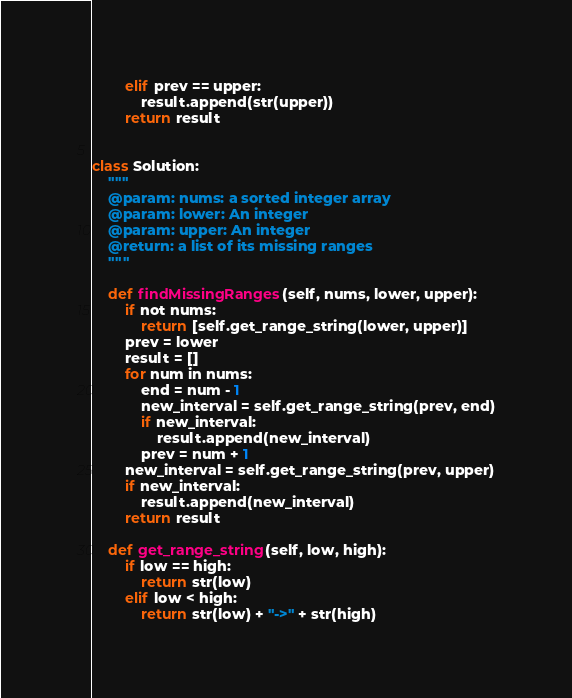<code> <loc_0><loc_0><loc_500><loc_500><_Python_>        elif prev == upper:
            result.append(str(upper))
        return result


class Solution:
    """
    @param: nums: a sorted integer array
    @param: lower: An integer
    @param: upper: An integer
    @return: a list of its missing ranges
    """

    def findMissingRanges(self, nums, lower, upper):
        if not nums:
            return [self.get_range_string(lower, upper)]
        prev = lower
        result = []
        for num in nums:
            end = num - 1
            new_interval = self.get_range_string(prev, end)
            if new_interval:
                result.append(new_interval)
            prev = num + 1
        new_interval = self.get_range_string(prev, upper)
        if new_interval:
            result.append(new_interval)
        return result

    def get_range_string(self, low, high):
        if low == high:
            return str(low)
        elif low < high:
            return str(low) + "->" + str(high)
</code> 